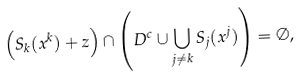Convert formula to latex. <formula><loc_0><loc_0><loc_500><loc_500>\left ( S _ { k } ( x ^ { k } ) + z \right ) \cap \left ( D ^ { c } \cup \bigcup _ { j \ne k } S _ { j } ( x ^ { j } ) \right ) = \emptyset ,</formula> 